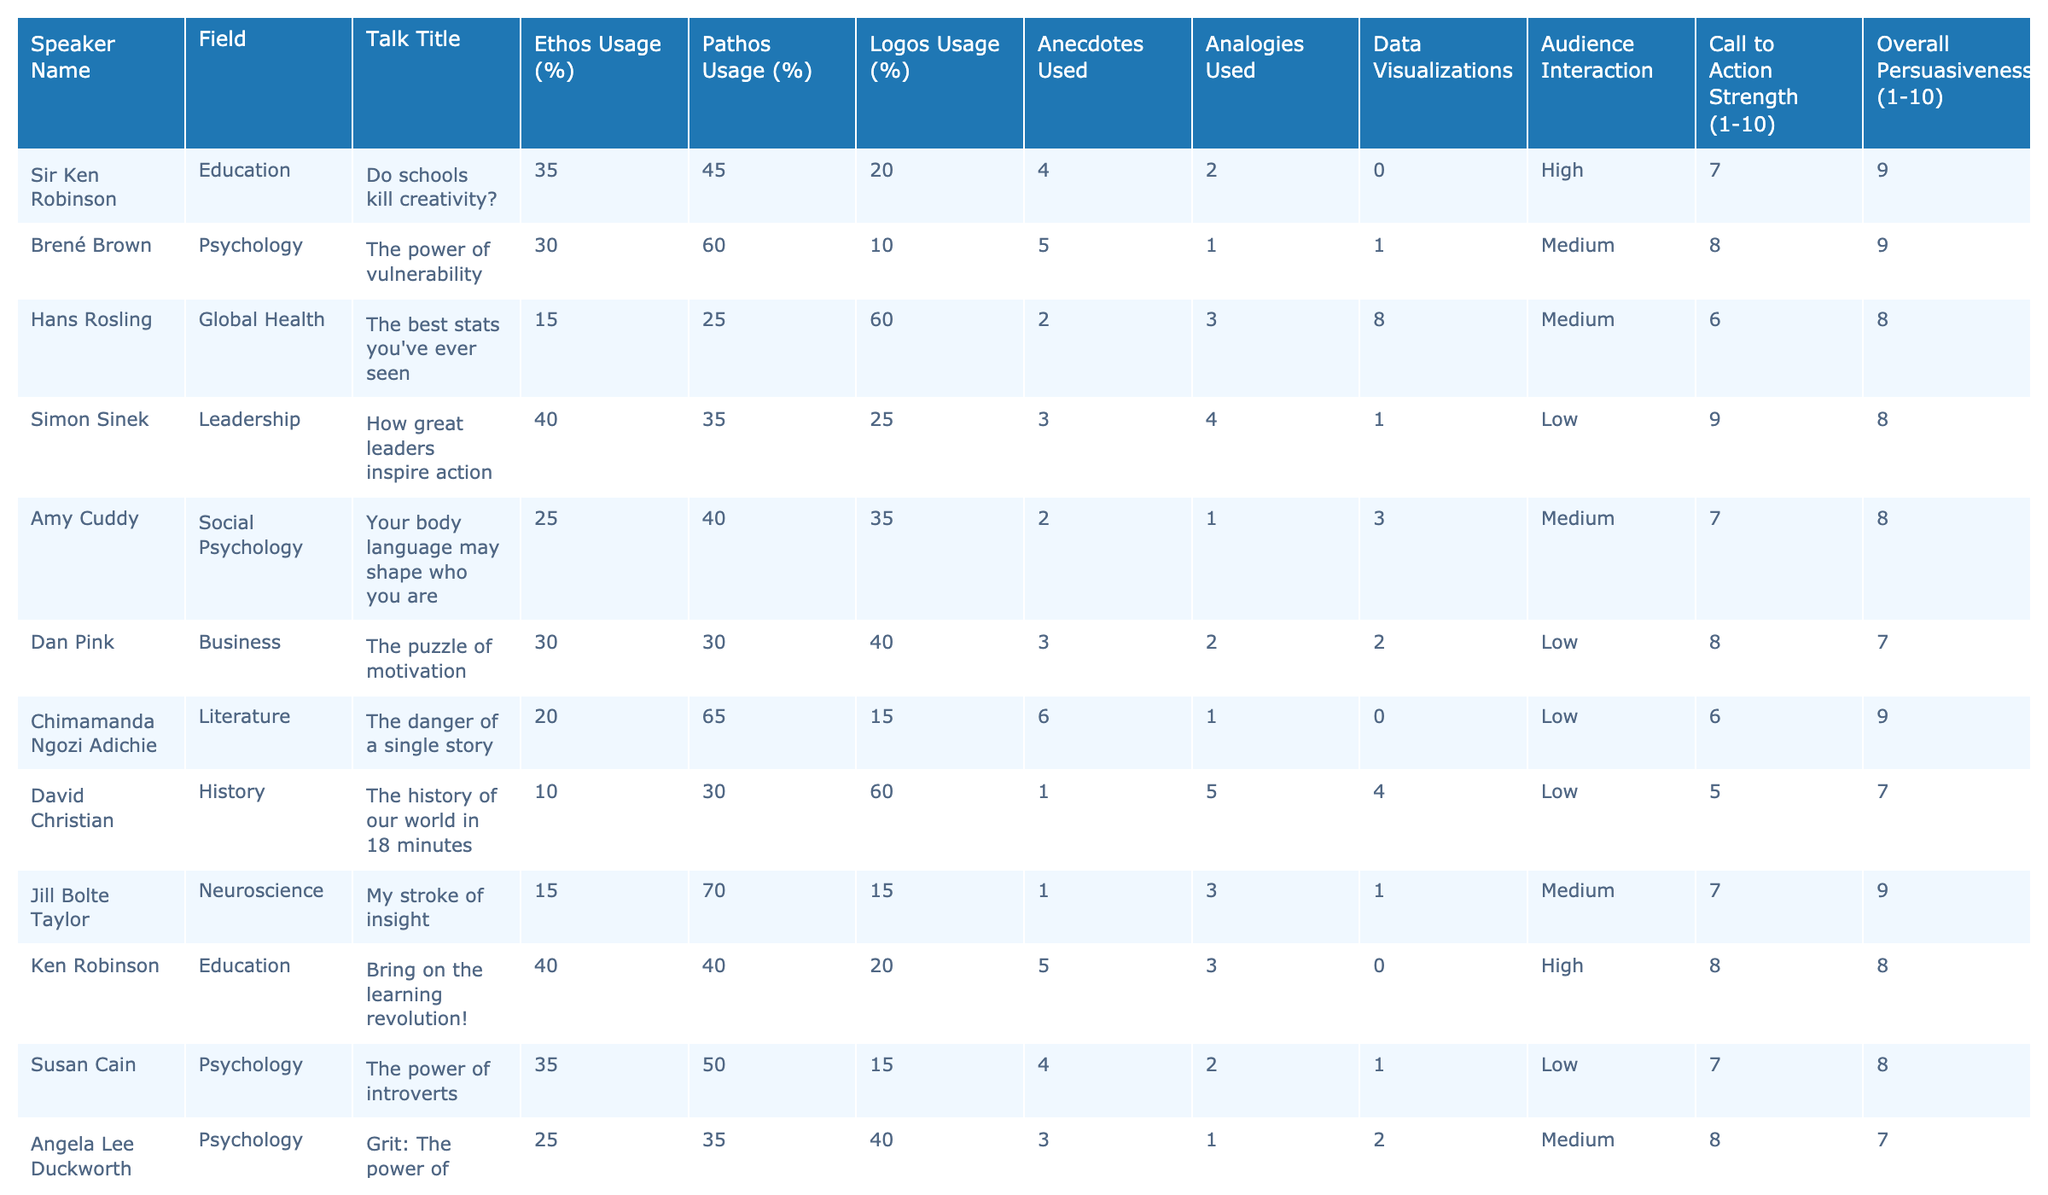What percentage of pathos usage did Jill Bolte Taylor employ in her talk? According to the table, Jill Bolte Taylor's pathos usage percentage is listed as 70%.
Answer: 70% Which speaker used the highest percentage of logos among the talks presented? After reviewing the logos usage column, Hans Rosling has the highest logos usage at 60%.
Answer: Hans Rosling What is the average call to action strength for speakers from the field of Psychology? To find the average, add the call to action strengths for Brené Brown (8), Amy Cuddy (7), Susan Cain (7), and Angela Lee Duckworth (8) for a total of 30. Then divide by the number of speakers in Psychology (4), resulting in 30/4 = 7.5.
Answer: 7.5 Did any speakers use no data visualizations in their talks? By inspecting the data visualizations column, both Sir Ken Robinson and Chimamanda Ngozi Adichie have a value of 0, indicating they did not use any data visualizations.
Answer: Yes Which speaker combined high pathos usage and a high overall persuasiveness rating? Examining the table, Brené Brown has 60% pathos usage and an overall persuasiveness rating of 9, making her the speaker who fits this criterion.
Answer: Brené Brown Calculate the difference between the highest logos usage and the lowest logos usage in the table. The highest logos usage is by Hans Rosling at 60%, and the lowest is by David Christian at 10%. The difference is 60 - 10 = 50.
Answer: 50 Is there any speaker whose overall persuasiveness score is higher than their ethos score? Reviewing the overall persuasiveness scores compared to ethos scores, Sir Ken Robinson has an ethos score of 35 and an overall persuasiveness score of 9, meaning it is indeed higher.
Answer: Yes What is the median of the call to action strengths for all speakers? First, we list the call to action strengths: 7, 8, 6, 5, 9, 8, 7, 6, 9, which when sorted gives: 5, 6, 6, 7, 7, 8, 8, 9, 9. The median values are 7 and 8; averaging them (7 + 8)/2 gives 7.5. Therefore, the median is 7.5.
Answer: 7.5 Which speaker from the field of Literature had the lowest ethos usage? By checking the ethos usage percentage for the speakers listed under Literature, Chimamanda Ngozi Adichie has the lowest ethos usage at 20%.
Answer: Chimamanda Ngozi Adichie How many speakers used anecdotes in their talks more than three times? Referring to the anecdotes used column, Jill Bolte Taylor (1), Ken Robinson (5), and Elizabeth Gilbert (5) are the only speakers who used anecdotes more than three times. Therefore, there are three speakers.
Answer: 3 